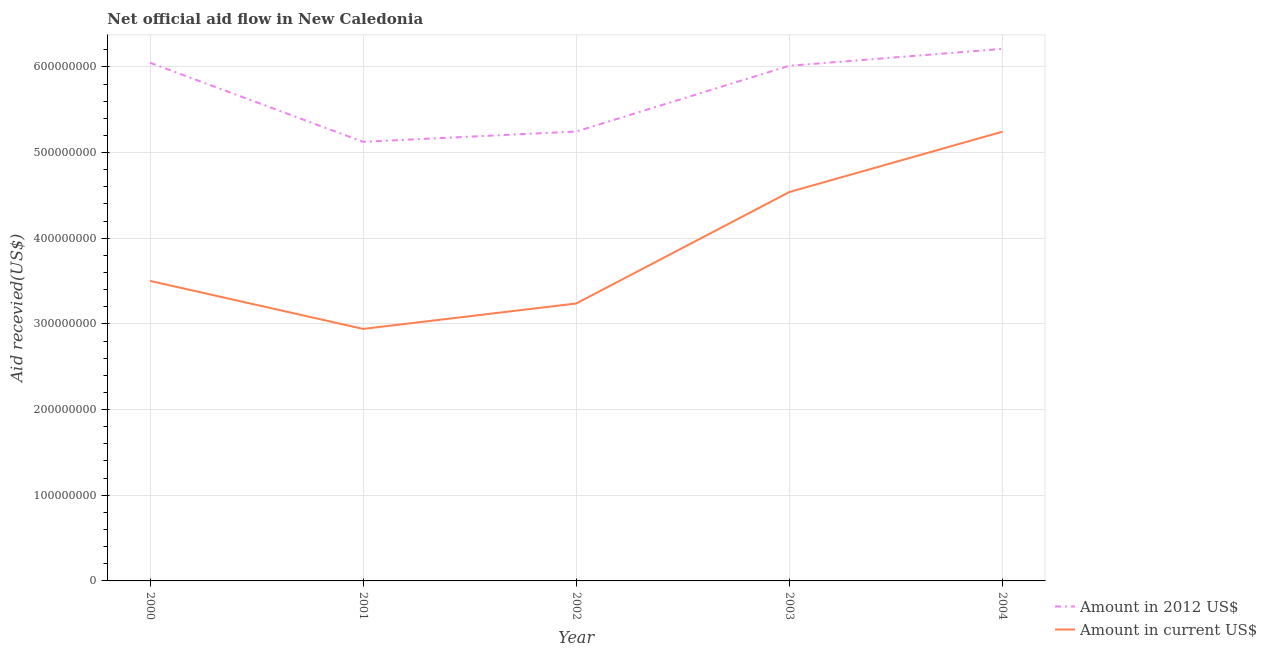Does the line corresponding to amount of aid received(expressed in 2012 us$) intersect with the line corresponding to amount of aid received(expressed in us$)?
Your response must be concise. No. Is the number of lines equal to the number of legend labels?
Offer a very short reply. Yes. What is the amount of aid received(expressed in 2012 us$) in 2000?
Your response must be concise. 6.05e+08. Across all years, what is the maximum amount of aid received(expressed in 2012 us$)?
Provide a short and direct response. 6.21e+08. Across all years, what is the minimum amount of aid received(expressed in 2012 us$)?
Your answer should be compact. 5.13e+08. In which year was the amount of aid received(expressed in 2012 us$) minimum?
Give a very brief answer. 2001. What is the total amount of aid received(expressed in us$) in the graph?
Provide a succinct answer. 1.95e+09. What is the difference between the amount of aid received(expressed in us$) in 2001 and that in 2003?
Offer a terse response. -1.60e+08. What is the difference between the amount of aid received(expressed in us$) in 2003 and the amount of aid received(expressed in 2012 us$) in 2004?
Make the answer very short. -1.67e+08. What is the average amount of aid received(expressed in us$) per year?
Provide a short and direct response. 3.89e+08. In the year 2000, what is the difference between the amount of aid received(expressed in 2012 us$) and amount of aid received(expressed in us$)?
Provide a succinct answer. 2.55e+08. What is the ratio of the amount of aid received(expressed in us$) in 2002 to that in 2003?
Your answer should be very brief. 0.71. Is the amount of aid received(expressed in us$) in 2002 less than that in 2003?
Offer a terse response. Yes. Is the difference between the amount of aid received(expressed in 2012 us$) in 2003 and 2004 greater than the difference between the amount of aid received(expressed in us$) in 2003 and 2004?
Provide a succinct answer. Yes. What is the difference between the highest and the second highest amount of aid received(expressed in us$)?
Your answer should be very brief. 7.04e+07. What is the difference between the highest and the lowest amount of aid received(expressed in us$)?
Your response must be concise. 2.30e+08. Is the amount of aid received(expressed in us$) strictly greater than the amount of aid received(expressed in 2012 us$) over the years?
Make the answer very short. No. Are the values on the major ticks of Y-axis written in scientific E-notation?
Provide a succinct answer. No. How are the legend labels stacked?
Provide a short and direct response. Vertical. What is the title of the graph?
Provide a succinct answer. Net official aid flow in New Caledonia. Does "Old" appear as one of the legend labels in the graph?
Provide a succinct answer. No. What is the label or title of the X-axis?
Provide a short and direct response. Year. What is the label or title of the Y-axis?
Your answer should be compact. Aid recevied(US$). What is the Aid recevied(US$) in Amount in 2012 US$ in 2000?
Offer a very short reply. 6.05e+08. What is the Aid recevied(US$) in Amount in current US$ in 2000?
Your answer should be very brief. 3.50e+08. What is the Aid recevied(US$) in Amount in 2012 US$ in 2001?
Give a very brief answer. 5.13e+08. What is the Aid recevied(US$) in Amount in current US$ in 2001?
Ensure brevity in your answer.  2.94e+08. What is the Aid recevied(US$) in Amount in 2012 US$ in 2002?
Your response must be concise. 5.25e+08. What is the Aid recevied(US$) in Amount in current US$ in 2002?
Provide a succinct answer. 3.24e+08. What is the Aid recevied(US$) of Amount in 2012 US$ in 2003?
Your answer should be compact. 6.01e+08. What is the Aid recevied(US$) of Amount in current US$ in 2003?
Provide a short and direct response. 4.54e+08. What is the Aid recevied(US$) in Amount in 2012 US$ in 2004?
Offer a very short reply. 6.21e+08. What is the Aid recevied(US$) in Amount in current US$ in 2004?
Give a very brief answer. 5.24e+08. Across all years, what is the maximum Aid recevied(US$) of Amount in 2012 US$?
Give a very brief answer. 6.21e+08. Across all years, what is the maximum Aid recevied(US$) of Amount in current US$?
Provide a short and direct response. 5.24e+08. Across all years, what is the minimum Aid recevied(US$) of Amount in 2012 US$?
Keep it short and to the point. 5.13e+08. Across all years, what is the minimum Aid recevied(US$) in Amount in current US$?
Provide a short and direct response. 2.94e+08. What is the total Aid recevied(US$) of Amount in 2012 US$ in the graph?
Give a very brief answer. 2.86e+09. What is the total Aid recevied(US$) in Amount in current US$ in the graph?
Offer a very short reply. 1.95e+09. What is the difference between the Aid recevied(US$) of Amount in 2012 US$ in 2000 and that in 2001?
Provide a succinct answer. 9.23e+07. What is the difference between the Aid recevied(US$) of Amount in current US$ in 2000 and that in 2001?
Your answer should be very brief. 5.60e+07. What is the difference between the Aid recevied(US$) in Amount in 2012 US$ in 2000 and that in 2002?
Provide a short and direct response. 8.02e+07. What is the difference between the Aid recevied(US$) of Amount in current US$ in 2000 and that in 2002?
Provide a short and direct response. 2.63e+07. What is the difference between the Aid recevied(US$) in Amount in 2012 US$ in 2000 and that in 2003?
Your answer should be very brief. 3.50e+06. What is the difference between the Aid recevied(US$) in Amount in current US$ in 2000 and that in 2003?
Offer a terse response. -1.04e+08. What is the difference between the Aid recevied(US$) in Amount in 2012 US$ in 2000 and that in 2004?
Your response must be concise. -1.62e+07. What is the difference between the Aid recevied(US$) in Amount in current US$ in 2000 and that in 2004?
Ensure brevity in your answer.  -1.74e+08. What is the difference between the Aid recevied(US$) of Amount in 2012 US$ in 2001 and that in 2002?
Offer a very short reply. -1.21e+07. What is the difference between the Aid recevied(US$) of Amount in current US$ in 2001 and that in 2002?
Your answer should be very brief. -2.97e+07. What is the difference between the Aid recevied(US$) of Amount in 2012 US$ in 2001 and that in 2003?
Keep it short and to the point. -8.88e+07. What is the difference between the Aid recevied(US$) of Amount in current US$ in 2001 and that in 2003?
Provide a succinct answer. -1.60e+08. What is the difference between the Aid recevied(US$) in Amount in 2012 US$ in 2001 and that in 2004?
Provide a short and direct response. -1.08e+08. What is the difference between the Aid recevied(US$) of Amount in current US$ in 2001 and that in 2004?
Your answer should be very brief. -2.30e+08. What is the difference between the Aid recevied(US$) in Amount in 2012 US$ in 2002 and that in 2003?
Offer a very short reply. -7.67e+07. What is the difference between the Aid recevied(US$) in Amount in current US$ in 2002 and that in 2003?
Offer a terse response. -1.30e+08. What is the difference between the Aid recevied(US$) in Amount in 2012 US$ in 2002 and that in 2004?
Ensure brevity in your answer.  -9.64e+07. What is the difference between the Aid recevied(US$) of Amount in current US$ in 2002 and that in 2004?
Offer a terse response. -2.01e+08. What is the difference between the Aid recevied(US$) in Amount in 2012 US$ in 2003 and that in 2004?
Provide a succinct answer. -1.97e+07. What is the difference between the Aid recevied(US$) of Amount in current US$ in 2003 and that in 2004?
Offer a very short reply. -7.04e+07. What is the difference between the Aid recevied(US$) of Amount in 2012 US$ in 2000 and the Aid recevied(US$) of Amount in current US$ in 2001?
Provide a short and direct response. 3.11e+08. What is the difference between the Aid recevied(US$) of Amount in 2012 US$ in 2000 and the Aid recevied(US$) of Amount in current US$ in 2002?
Provide a succinct answer. 2.81e+08. What is the difference between the Aid recevied(US$) in Amount in 2012 US$ in 2000 and the Aid recevied(US$) in Amount in current US$ in 2003?
Make the answer very short. 1.51e+08. What is the difference between the Aid recevied(US$) of Amount in 2012 US$ in 2000 and the Aid recevied(US$) of Amount in current US$ in 2004?
Make the answer very short. 8.05e+07. What is the difference between the Aid recevied(US$) in Amount in 2012 US$ in 2001 and the Aid recevied(US$) in Amount in current US$ in 2002?
Ensure brevity in your answer.  1.89e+08. What is the difference between the Aid recevied(US$) in Amount in 2012 US$ in 2001 and the Aid recevied(US$) in Amount in current US$ in 2003?
Make the answer very short. 5.86e+07. What is the difference between the Aid recevied(US$) of Amount in 2012 US$ in 2001 and the Aid recevied(US$) of Amount in current US$ in 2004?
Provide a succinct answer. -1.18e+07. What is the difference between the Aid recevied(US$) in Amount in 2012 US$ in 2002 and the Aid recevied(US$) in Amount in current US$ in 2003?
Your answer should be compact. 7.07e+07. What is the difference between the Aid recevied(US$) in Amount in 2012 US$ in 2002 and the Aid recevied(US$) in Amount in current US$ in 2004?
Your answer should be compact. 2.50e+05. What is the difference between the Aid recevied(US$) in Amount in 2012 US$ in 2003 and the Aid recevied(US$) in Amount in current US$ in 2004?
Offer a very short reply. 7.70e+07. What is the average Aid recevied(US$) of Amount in 2012 US$ per year?
Make the answer very short. 5.73e+08. What is the average Aid recevied(US$) in Amount in current US$ per year?
Provide a succinct answer. 3.89e+08. In the year 2000, what is the difference between the Aid recevied(US$) of Amount in 2012 US$ and Aid recevied(US$) of Amount in current US$?
Ensure brevity in your answer.  2.55e+08. In the year 2001, what is the difference between the Aid recevied(US$) of Amount in 2012 US$ and Aid recevied(US$) of Amount in current US$?
Provide a succinct answer. 2.18e+08. In the year 2002, what is the difference between the Aid recevied(US$) of Amount in 2012 US$ and Aid recevied(US$) of Amount in current US$?
Provide a short and direct response. 2.01e+08. In the year 2003, what is the difference between the Aid recevied(US$) of Amount in 2012 US$ and Aid recevied(US$) of Amount in current US$?
Your answer should be very brief. 1.47e+08. In the year 2004, what is the difference between the Aid recevied(US$) of Amount in 2012 US$ and Aid recevied(US$) of Amount in current US$?
Offer a terse response. 9.67e+07. What is the ratio of the Aid recevied(US$) of Amount in 2012 US$ in 2000 to that in 2001?
Make the answer very short. 1.18. What is the ratio of the Aid recevied(US$) of Amount in current US$ in 2000 to that in 2001?
Provide a succinct answer. 1.19. What is the ratio of the Aid recevied(US$) of Amount in 2012 US$ in 2000 to that in 2002?
Your answer should be very brief. 1.15. What is the ratio of the Aid recevied(US$) of Amount in current US$ in 2000 to that in 2002?
Provide a succinct answer. 1.08. What is the ratio of the Aid recevied(US$) of Amount in current US$ in 2000 to that in 2003?
Offer a very short reply. 0.77. What is the ratio of the Aid recevied(US$) in Amount in 2012 US$ in 2000 to that in 2004?
Make the answer very short. 0.97. What is the ratio of the Aid recevied(US$) in Amount in current US$ in 2000 to that in 2004?
Keep it short and to the point. 0.67. What is the ratio of the Aid recevied(US$) in Amount in 2012 US$ in 2001 to that in 2002?
Your answer should be compact. 0.98. What is the ratio of the Aid recevied(US$) in Amount in current US$ in 2001 to that in 2002?
Give a very brief answer. 0.91. What is the ratio of the Aid recevied(US$) in Amount in 2012 US$ in 2001 to that in 2003?
Offer a terse response. 0.85. What is the ratio of the Aid recevied(US$) of Amount in current US$ in 2001 to that in 2003?
Provide a succinct answer. 0.65. What is the ratio of the Aid recevied(US$) of Amount in 2012 US$ in 2001 to that in 2004?
Your answer should be very brief. 0.83. What is the ratio of the Aid recevied(US$) in Amount in current US$ in 2001 to that in 2004?
Keep it short and to the point. 0.56. What is the ratio of the Aid recevied(US$) of Amount in 2012 US$ in 2002 to that in 2003?
Your answer should be compact. 0.87. What is the ratio of the Aid recevied(US$) of Amount in current US$ in 2002 to that in 2003?
Ensure brevity in your answer.  0.71. What is the ratio of the Aid recevied(US$) of Amount in 2012 US$ in 2002 to that in 2004?
Offer a terse response. 0.84. What is the ratio of the Aid recevied(US$) in Amount in current US$ in 2002 to that in 2004?
Your answer should be compact. 0.62. What is the ratio of the Aid recevied(US$) of Amount in 2012 US$ in 2003 to that in 2004?
Keep it short and to the point. 0.97. What is the ratio of the Aid recevied(US$) of Amount in current US$ in 2003 to that in 2004?
Your response must be concise. 0.87. What is the difference between the highest and the second highest Aid recevied(US$) in Amount in 2012 US$?
Your response must be concise. 1.62e+07. What is the difference between the highest and the second highest Aid recevied(US$) in Amount in current US$?
Keep it short and to the point. 7.04e+07. What is the difference between the highest and the lowest Aid recevied(US$) of Amount in 2012 US$?
Ensure brevity in your answer.  1.08e+08. What is the difference between the highest and the lowest Aid recevied(US$) of Amount in current US$?
Ensure brevity in your answer.  2.30e+08. 